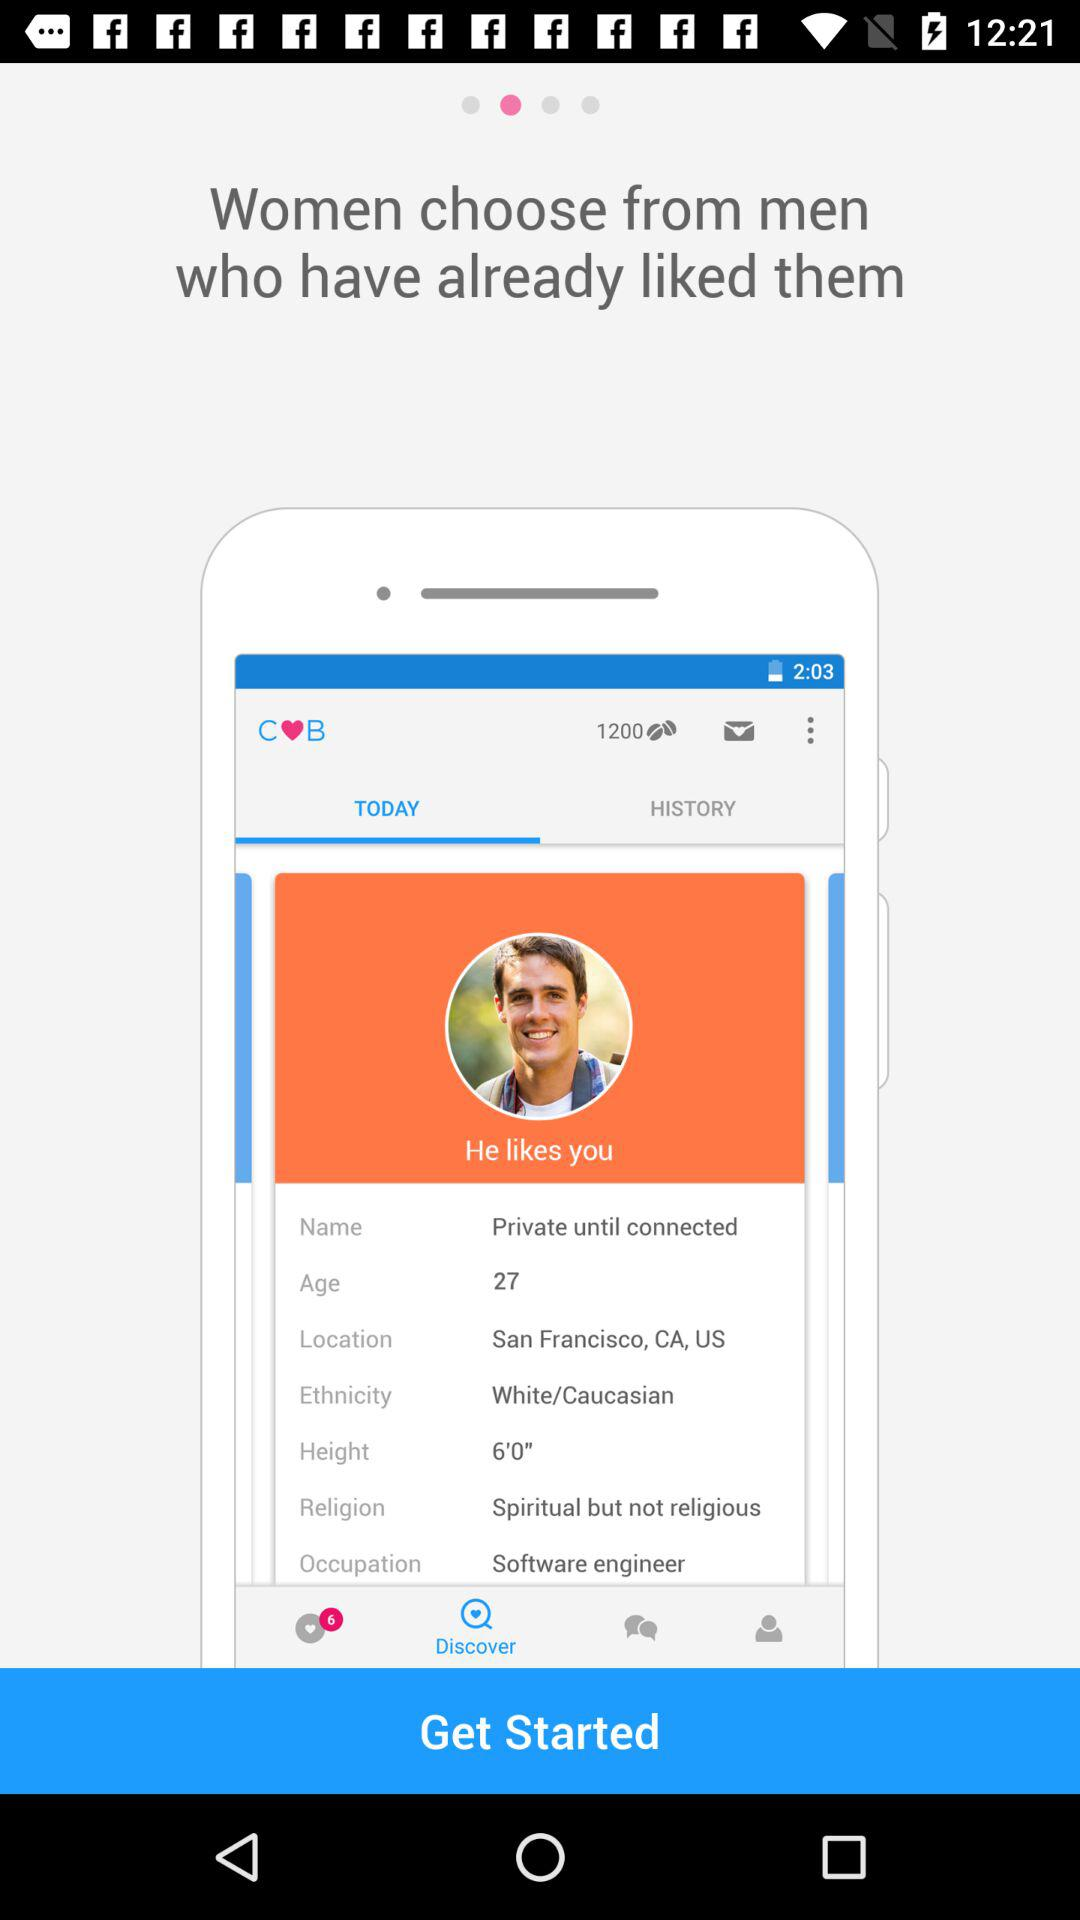What is the name shown on the screen? The name shown on the screen is "Private until connected". 